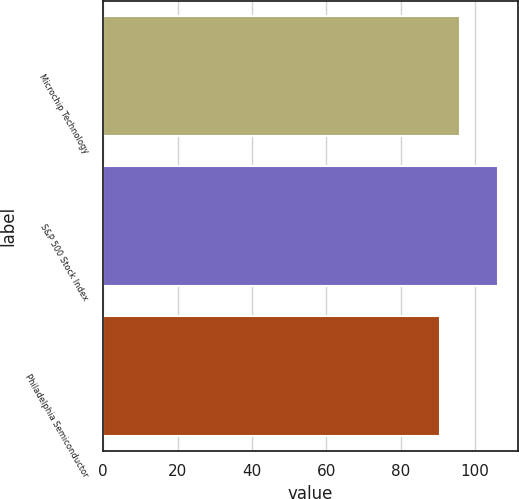Convert chart to OTSL. <chart><loc_0><loc_0><loc_500><loc_500><bar_chart><fcel>Microchip Technology<fcel>S&P 500 Stock Index<fcel>Philadelphia Semiconductor<nl><fcel>96<fcel>106.15<fcel>90.68<nl></chart> 